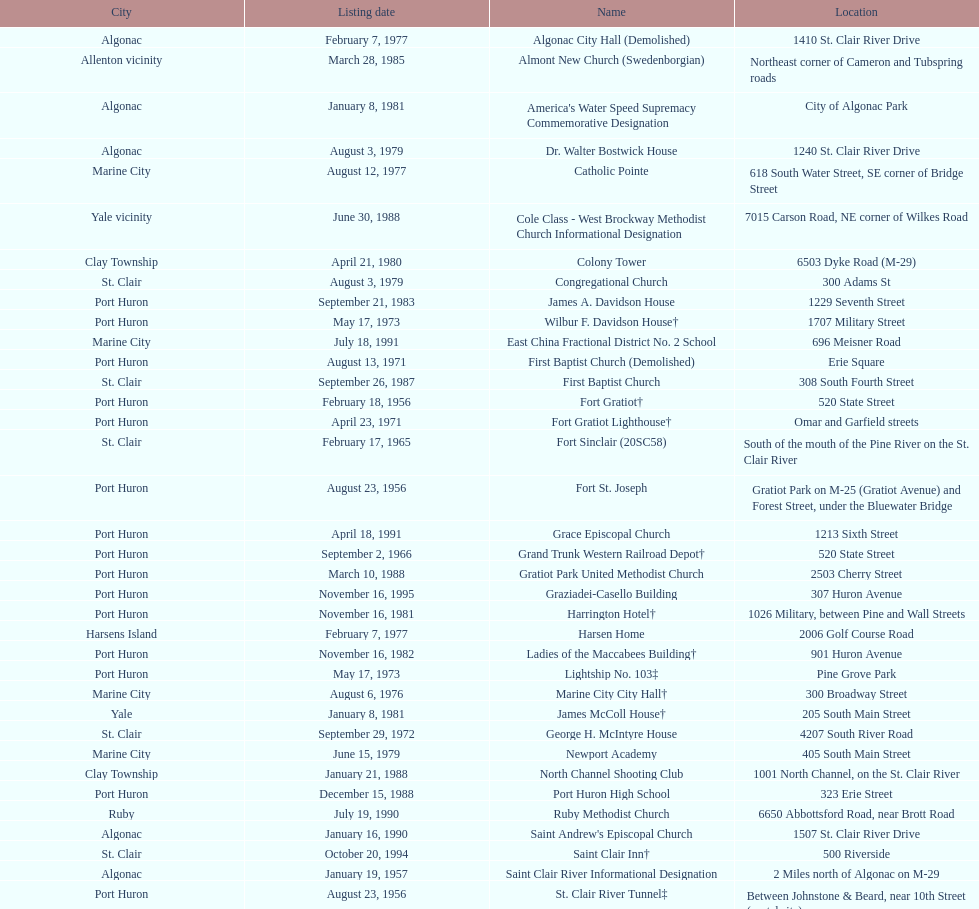What is the number of properties on the list that have been demolished? 2. Can you give me this table as a dict? {'header': ['City', 'Listing date', 'Name', 'Location'], 'rows': [['Algonac', 'February 7, 1977', 'Algonac City Hall (Demolished)', '1410 St. Clair River Drive'], ['Allenton vicinity', 'March 28, 1985', 'Almont New Church (Swedenborgian)', 'Northeast corner of Cameron and Tubspring roads'], ['Algonac', 'January 8, 1981', "America's Water Speed Supremacy Commemorative Designation", 'City of Algonac Park'], ['Algonac', 'August 3, 1979', 'Dr. Walter Bostwick House', '1240 St. Clair River Drive'], ['Marine City', 'August 12, 1977', 'Catholic Pointe', '618 South Water Street, SE corner of Bridge Street'], ['Yale vicinity', 'June 30, 1988', 'Cole Class - West Brockway Methodist Church Informational Designation', '7015 Carson Road, NE corner of Wilkes Road'], ['Clay Township', 'April 21, 1980', 'Colony Tower', '6503 Dyke Road (M-29)'], ['St. Clair', 'August 3, 1979', 'Congregational Church', '300 Adams St'], ['Port Huron', 'September 21, 1983', 'James A. Davidson House', '1229 Seventh Street'], ['Port Huron', 'May 17, 1973', 'Wilbur F. Davidson House†', '1707 Military Street'], ['Marine City', 'July 18, 1991', 'East China Fractional District No. 2 School', '696 Meisner Road'], ['Port Huron', 'August 13, 1971', 'First Baptist Church (Demolished)', 'Erie Square'], ['St. Clair', 'September 26, 1987', 'First Baptist Church', '308 South Fourth Street'], ['Port Huron', 'February 18, 1956', 'Fort Gratiot†', '520 State Street'], ['Port Huron', 'April 23, 1971', 'Fort Gratiot Lighthouse†', 'Omar and Garfield streets'], ['St. Clair', 'February 17, 1965', 'Fort Sinclair (20SC58)', 'South of the mouth of the Pine River on the St. Clair River'], ['Port Huron', 'August 23, 1956', 'Fort St. Joseph', 'Gratiot Park on M-25 (Gratiot Avenue) and Forest Street, under the Bluewater Bridge'], ['Port Huron', 'April 18, 1991', 'Grace Episcopal Church', '1213 Sixth Street'], ['Port Huron', 'September 2, 1966', 'Grand Trunk Western Railroad Depot†', '520 State Street'], ['Port Huron', 'March 10, 1988', 'Gratiot Park United Methodist Church', '2503 Cherry Street'], ['Port Huron', 'November 16, 1995', 'Graziadei-Casello Building', '307 Huron Avenue'], ['Port Huron', 'November 16, 1981', 'Harrington Hotel†', '1026 Military, between Pine and Wall Streets'], ['Harsens Island', 'February 7, 1977', 'Harsen Home', '2006 Golf Course Road'], ['Port Huron', 'November 16, 1982', 'Ladies of the Maccabees Building†', '901 Huron Avenue'], ['Port Huron', 'May 17, 1973', 'Lightship No. 103‡', 'Pine Grove Park'], ['Marine City', 'August 6, 1976', 'Marine City City Hall†', '300 Broadway Street'], ['Yale', 'January 8, 1981', 'James McColl House†', '205 South Main Street'], ['St. Clair', 'September 29, 1972', 'George H. McIntyre House', '4207 South River Road'], ['Marine City', 'June 15, 1979', 'Newport Academy', '405 South Main Street'], ['Clay Township', 'January 21, 1988', 'North Channel Shooting Club', '1001 North Channel, on the St. Clair River'], ['Port Huron', 'December 15, 1988', 'Port Huron High School', '323 Erie Street'], ['Ruby', 'July 19, 1990', 'Ruby Methodist Church', '6650 Abbottsford Road, near Brott Road'], ['Algonac', 'January 16, 1990', "Saint Andrew's Episcopal Church", '1507 St. Clair River Drive'], ['St. Clair', 'October 20, 1994', 'Saint Clair Inn†', '500 Riverside'], ['Algonac', 'January 19, 1957', 'Saint Clair River Informational Designation', '2 Miles north of Algonac on M-29'], ['Port Huron', 'August 23, 1956', 'St. Clair River Tunnel‡', 'Between Johnstone & Beard, near 10th Street (portal site)'], ['Port Huron', 'March 19, 1980', 'Saint Johannes Evangelische Kirche', '710 Pine Street, at Seventh Street'], ['St. Clair', 'September 25, 1985', "Saint Mary's Catholic Church and Rectory", '415 North Sixth Street, between Vine and Orchard streets'], ['Port Huron', 'April 19, 1990', 'Jefferson Sheldon House', '807 Prospect Place'], ['Port Huron', 'August 29, 1996', 'Trinity Evangelical Lutheran Church', '1517 Tenth Street'], ['Wales Township', 'July 18, 1996', 'Wales Township Hall', '1372 Wales Center'], ['Marine City', 'May 5, 1964', 'Ward-Holland House†', '433 North Main Street'], ['Port Huron', 'November 18, 1993', 'E. C. Williams House', '2511 Tenth Avenue, between Hancock and Church streets'], ['Marysville', 'June 23, 1983', 'C. H. Wills & Company', 'Chrysler Plant, 840 Huron Avenue'], ['Port Huron', 'December 15, 1988', "Woman's Benefit Association Building", '1338 Military Street']]} 